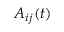<formula> <loc_0><loc_0><loc_500><loc_500>A _ { i j } ( t )</formula> 